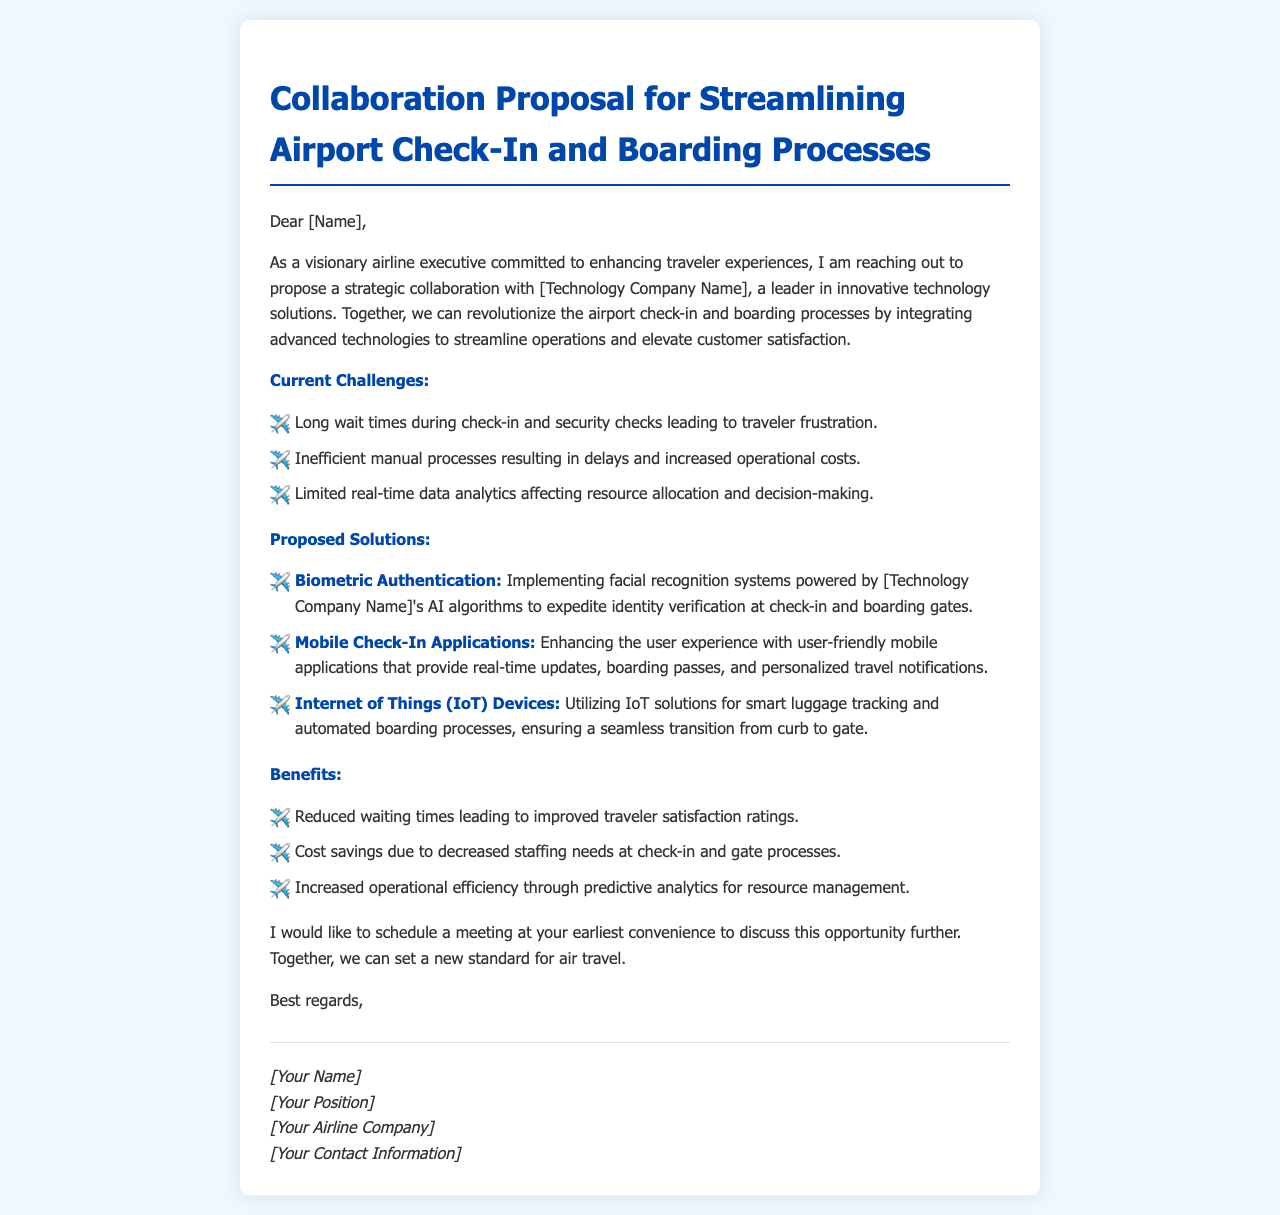What is the title of the proposal? The title is provided at the beginning of the document and is "Collaboration Proposal for Streamlining Airport Check-In and Boarding Processes."
Answer: Collaboration Proposal for Streamlining Airport Check-In and Boarding Processes Who is the email addressed to? The email starts with "Dear [Name]," indicating that it is addressed to an unspecified individual and typically would contain the recipient's name.
Answer: [Name] What technology is proposed for identity verification? The document mentions implementing biometric authentication powered by AI algorithms for expedited identity verification.
Answer: Biometric Authentication What are the three current challenges listed? The challenges are outlined in a bulleted list: long wait times, inefficient manual processes, and limited real-time data analytics.
Answer: Long wait times, inefficient manual processes, limited real-time data analytics What is one key benefit of implementing the proposed solutions? The email highlights reduced waiting times as one of the benefits leading to improved traveler satisfaction ratings.
Answer: Reduced waiting times How many proposed solutions are mentioned? The document lists three specific proposed solutions for streamlining airport operations.
Answer: Three What does the sender request at the end of the email? The sender expresses a desire to schedule a meeting to discuss the collaboration opportunity further.
Answer: Schedule a meeting Who is the sender of the email? The signature section contains placeholders for the sender's name, position, airline company, and contact information.
Answer: [Your Name] 